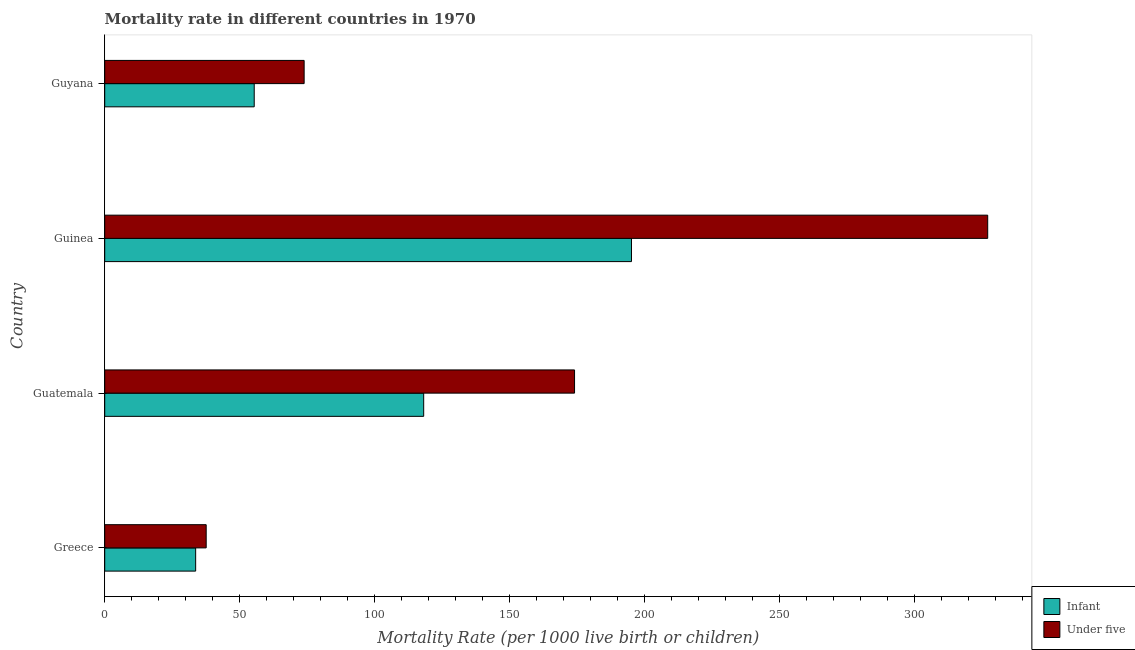How many different coloured bars are there?
Provide a succinct answer. 2. What is the label of the 3rd group of bars from the top?
Offer a very short reply. Guatemala. What is the under-5 mortality rate in Greece?
Offer a very short reply. 37.6. Across all countries, what is the maximum under-5 mortality rate?
Your response must be concise. 327.2. Across all countries, what is the minimum infant mortality rate?
Give a very brief answer. 33.7. In which country was the under-5 mortality rate maximum?
Keep it short and to the point. Guinea. What is the total under-5 mortality rate in the graph?
Your answer should be compact. 612.8. What is the difference between the under-5 mortality rate in Greece and that in Guinea?
Provide a short and direct response. -289.6. What is the difference between the infant mortality rate in Guyana and the under-5 mortality rate in Guinea?
Your answer should be very brief. -271.8. What is the average under-5 mortality rate per country?
Give a very brief answer. 153.2. What is the difference between the under-5 mortality rate and infant mortality rate in Guatemala?
Offer a terse response. 55.9. What is the ratio of the infant mortality rate in Greece to that in Guyana?
Offer a very short reply. 0.61. Is the difference between the under-5 mortality rate in Guatemala and Guinea greater than the difference between the infant mortality rate in Guatemala and Guinea?
Offer a terse response. No. What is the difference between the highest and the second highest infant mortality rate?
Provide a short and direct response. 77. What is the difference between the highest and the lowest infant mortality rate?
Give a very brief answer. 161.5. In how many countries, is the under-5 mortality rate greater than the average under-5 mortality rate taken over all countries?
Ensure brevity in your answer.  2. Is the sum of the infant mortality rate in Greece and Guyana greater than the maximum under-5 mortality rate across all countries?
Provide a short and direct response. No. What does the 2nd bar from the top in Greece represents?
Provide a succinct answer. Infant. What does the 2nd bar from the bottom in Guyana represents?
Provide a short and direct response. Under five. How many bars are there?
Give a very brief answer. 8. Are all the bars in the graph horizontal?
Your response must be concise. Yes. How many countries are there in the graph?
Ensure brevity in your answer.  4. Are the values on the major ticks of X-axis written in scientific E-notation?
Your answer should be very brief. No. Does the graph contain grids?
Offer a very short reply. No. Where does the legend appear in the graph?
Ensure brevity in your answer.  Bottom right. What is the title of the graph?
Your answer should be compact. Mortality rate in different countries in 1970. Does "Private funds" appear as one of the legend labels in the graph?
Your response must be concise. No. What is the label or title of the X-axis?
Provide a succinct answer. Mortality Rate (per 1000 live birth or children). What is the Mortality Rate (per 1000 live birth or children) in Infant in Greece?
Your answer should be compact. 33.7. What is the Mortality Rate (per 1000 live birth or children) in Under five in Greece?
Keep it short and to the point. 37.6. What is the Mortality Rate (per 1000 live birth or children) in Infant in Guatemala?
Give a very brief answer. 118.2. What is the Mortality Rate (per 1000 live birth or children) in Under five in Guatemala?
Give a very brief answer. 174.1. What is the Mortality Rate (per 1000 live birth or children) of Infant in Guinea?
Ensure brevity in your answer.  195.2. What is the Mortality Rate (per 1000 live birth or children) in Under five in Guinea?
Your answer should be very brief. 327.2. What is the Mortality Rate (per 1000 live birth or children) in Infant in Guyana?
Provide a short and direct response. 55.4. What is the Mortality Rate (per 1000 live birth or children) of Under five in Guyana?
Provide a short and direct response. 73.9. Across all countries, what is the maximum Mortality Rate (per 1000 live birth or children) of Infant?
Keep it short and to the point. 195.2. Across all countries, what is the maximum Mortality Rate (per 1000 live birth or children) in Under five?
Keep it short and to the point. 327.2. Across all countries, what is the minimum Mortality Rate (per 1000 live birth or children) of Infant?
Your answer should be very brief. 33.7. Across all countries, what is the minimum Mortality Rate (per 1000 live birth or children) of Under five?
Keep it short and to the point. 37.6. What is the total Mortality Rate (per 1000 live birth or children) in Infant in the graph?
Make the answer very short. 402.5. What is the total Mortality Rate (per 1000 live birth or children) of Under five in the graph?
Offer a terse response. 612.8. What is the difference between the Mortality Rate (per 1000 live birth or children) in Infant in Greece and that in Guatemala?
Give a very brief answer. -84.5. What is the difference between the Mortality Rate (per 1000 live birth or children) of Under five in Greece and that in Guatemala?
Offer a very short reply. -136.5. What is the difference between the Mortality Rate (per 1000 live birth or children) of Infant in Greece and that in Guinea?
Ensure brevity in your answer.  -161.5. What is the difference between the Mortality Rate (per 1000 live birth or children) of Under five in Greece and that in Guinea?
Keep it short and to the point. -289.6. What is the difference between the Mortality Rate (per 1000 live birth or children) in Infant in Greece and that in Guyana?
Make the answer very short. -21.7. What is the difference between the Mortality Rate (per 1000 live birth or children) of Under five in Greece and that in Guyana?
Give a very brief answer. -36.3. What is the difference between the Mortality Rate (per 1000 live birth or children) of Infant in Guatemala and that in Guinea?
Offer a very short reply. -77. What is the difference between the Mortality Rate (per 1000 live birth or children) in Under five in Guatemala and that in Guinea?
Your answer should be very brief. -153.1. What is the difference between the Mortality Rate (per 1000 live birth or children) of Infant in Guatemala and that in Guyana?
Your answer should be very brief. 62.8. What is the difference between the Mortality Rate (per 1000 live birth or children) in Under five in Guatemala and that in Guyana?
Your response must be concise. 100.2. What is the difference between the Mortality Rate (per 1000 live birth or children) in Infant in Guinea and that in Guyana?
Provide a succinct answer. 139.8. What is the difference between the Mortality Rate (per 1000 live birth or children) in Under five in Guinea and that in Guyana?
Your answer should be very brief. 253.3. What is the difference between the Mortality Rate (per 1000 live birth or children) of Infant in Greece and the Mortality Rate (per 1000 live birth or children) of Under five in Guatemala?
Your answer should be compact. -140.4. What is the difference between the Mortality Rate (per 1000 live birth or children) of Infant in Greece and the Mortality Rate (per 1000 live birth or children) of Under five in Guinea?
Provide a short and direct response. -293.5. What is the difference between the Mortality Rate (per 1000 live birth or children) of Infant in Greece and the Mortality Rate (per 1000 live birth or children) of Under five in Guyana?
Provide a succinct answer. -40.2. What is the difference between the Mortality Rate (per 1000 live birth or children) of Infant in Guatemala and the Mortality Rate (per 1000 live birth or children) of Under five in Guinea?
Keep it short and to the point. -209. What is the difference between the Mortality Rate (per 1000 live birth or children) in Infant in Guatemala and the Mortality Rate (per 1000 live birth or children) in Under five in Guyana?
Keep it short and to the point. 44.3. What is the difference between the Mortality Rate (per 1000 live birth or children) of Infant in Guinea and the Mortality Rate (per 1000 live birth or children) of Under five in Guyana?
Keep it short and to the point. 121.3. What is the average Mortality Rate (per 1000 live birth or children) of Infant per country?
Your response must be concise. 100.62. What is the average Mortality Rate (per 1000 live birth or children) in Under five per country?
Your response must be concise. 153.2. What is the difference between the Mortality Rate (per 1000 live birth or children) in Infant and Mortality Rate (per 1000 live birth or children) in Under five in Guatemala?
Offer a very short reply. -55.9. What is the difference between the Mortality Rate (per 1000 live birth or children) of Infant and Mortality Rate (per 1000 live birth or children) of Under five in Guinea?
Provide a short and direct response. -132. What is the difference between the Mortality Rate (per 1000 live birth or children) of Infant and Mortality Rate (per 1000 live birth or children) of Under five in Guyana?
Your answer should be compact. -18.5. What is the ratio of the Mortality Rate (per 1000 live birth or children) in Infant in Greece to that in Guatemala?
Ensure brevity in your answer.  0.29. What is the ratio of the Mortality Rate (per 1000 live birth or children) of Under five in Greece to that in Guatemala?
Your answer should be very brief. 0.22. What is the ratio of the Mortality Rate (per 1000 live birth or children) in Infant in Greece to that in Guinea?
Your answer should be compact. 0.17. What is the ratio of the Mortality Rate (per 1000 live birth or children) of Under five in Greece to that in Guinea?
Ensure brevity in your answer.  0.11. What is the ratio of the Mortality Rate (per 1000 live birth or children) in Infant in Greece to that in Guyana?
Make the answer very short. 0.61. What is the ratio of the Mortality Rate (per 1000 live birth or children) in Under five in Greece to that in Guyana?
Your response must be concise. 0.51. What is the ratio of the Mortality Rate (per 1000 live birth or children) in Infant in Guatemala to that in Guinea?
Keep it short and to the point. 0.61. What is the ratio of the Mortality Rate (per 1000 live birth or children) in Under five in Guatemala to that in Guinea?
Your response must be concise. 0.53. What is the ratio of the Mortality Rate (per 1000 live birth or children) in Infant in Guatemala to that in Guyana?
Your response must be concise. 2.13. What is the ratio of the Mortality Rate (per 1000 live birth or children) of Under five in Guatemala to that in Guyana?
Your answer should be very brief. 2.36. What is the ratio of the Mortality Rate (per 1000 live birth or children) of Infant in Guinea to that in Guyana?
Give a very brief answer. 3.52. What is the ratio of the Mortality Rate (per 1000 live birth or children) in Under five in Guinea to that in Guyana?
Provide a short and direct response. 4.43. What is the difference between the highest and the second highest Mortality Rate (per 1000 live birth or children) in Under five?
Offer a terse response. 153.1. What is the difference between the highest and the lowest Mortality Rate (per 1000 live birth or children) in Infant?
Your answer should be compact. 161.5. What is the difference between the highest and the lowest Mortality Rate (per 1000 live birth or children) in Under five?
Make the answer very short. 289.6. 